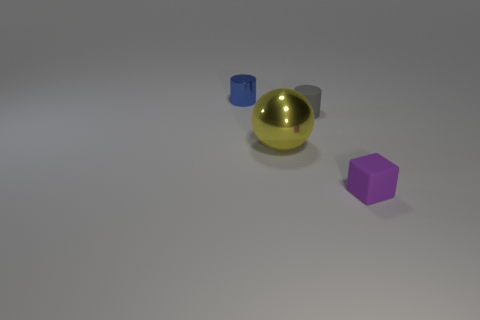Add 3 small gray rubber objects. How many objects exist? 7 Subtract all blue cylinders. How many cylinders are left? 1 Subtract 1 balls. How many balls are left? 0 Subtract 0 red cylinders. How many objects are left? 4 Subtract all spheres. How many objects are left? 3 Subtract all yellow cubes. Subtract all purple cylinders. How many cubes are left? 1 Subtract all small blue metal cylinders. Subtract all metal things. How many objects are left? 1 Add 2 shiny balls. How many shiny balls are left? 3 Add 4 metallic objects. How many metallic objects exist? 6 